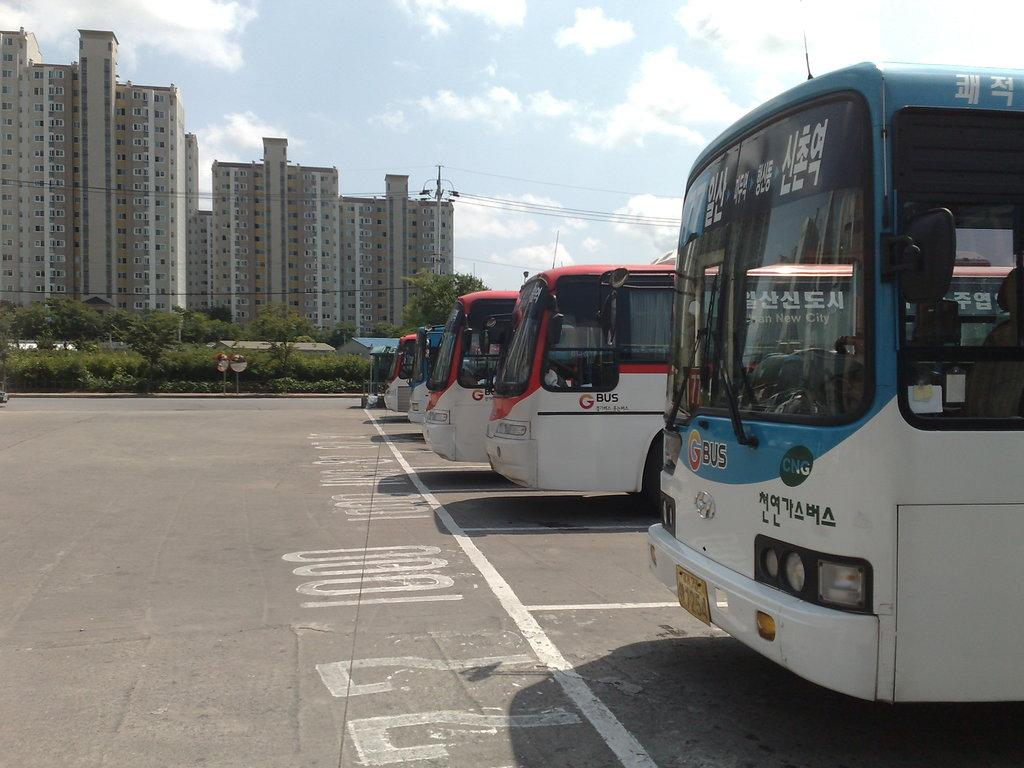<image>
Give a short and clear explanation of the subsequent image. Buses parked in a parking lot with one that says "CNG" on it. 